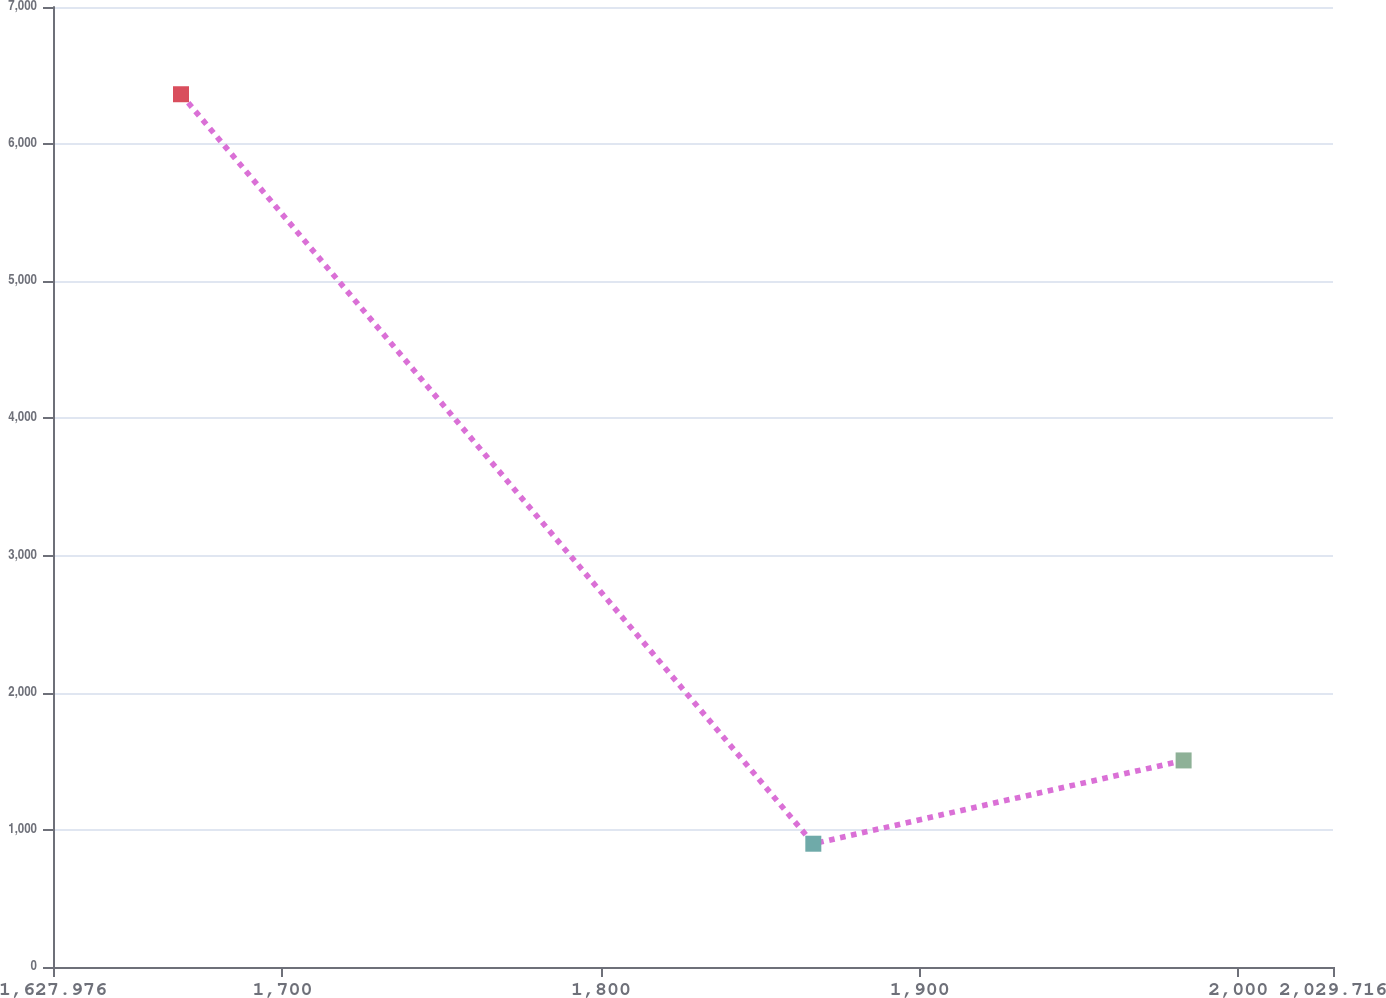<chart> <loc_0><loc_0><loc_500><loc_500><line_chart><ecel><fcel>Unnamed: 1<nl><fcel>1668.15<fcel>6363.86<nl><fcel>1866.61<fcel>898.99<nl><fcel>1982.83<fcel>1506.2<nl><fcel>2069.89<fcel>291.78<nl></chart> 